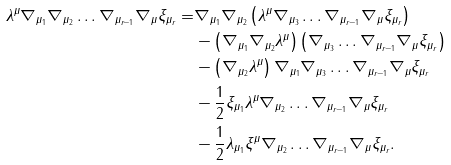Convert formula to latex. <formula><loc_0><loc_0><loc_500><loc_500>\lambda ^ { \mu } \nabla _ { \mu _ { 1 } } \nabla _ { \mu _ { 2 } } \dots \nabla _ { \mu _ { r - 1 } } \nabla _ { \mu } \xi _ { \mu _ { r } } = & \nabla _ { \mu _ { 1 } } \nabla _ { \mu _ { 2 } } \left ( \lambda ^ { \mu } \nabla _ { \mu _ { 3 } } \dots \nabla _ { \mu _ { r - 1 } } \nabla _ { \mu } \xi _ { \mu _ { r } } \right ) \\ & - \left ( \nabla _ { \mu _ { 1 } } \nabla _ { \mu _ { 2 } } \lambda ^ { \mu } \right ) \left ( \nabla _ { \mu _ { 3 } } \dots \nabla _ { \mu _ { r - 1 } } \nabla _ { \mu } \xi _ { \mu _ { r } } \right ) \\ & - \left ( \nabla _ { \mu _ { 2 } } \lambda ^ { \mu } \right ) \nabla _ { \mu _ { 1 } } \nabla _ { \mu _ { 3 } } \dots \nabla _ { \mu _ { r - 1 } } \nabla _ { \mu } \xi _ { \mu _ { r } } \\ & - \frac { 1 } { 2 } \xi _ { \mu _ { 1 } } \lambda ^ { \mu } \nabla _ { \mu _ { 2 } } \dots \nabla _ { \mu _ { r - 1 } } \nabla _ { \mu } \xi _ { \mu _ { r } } \\ & - \frac { 1 } { 2 } \lambda _ { \mu _ { 1 } } \xi ^ { \mu } \nabla _ { \mu _ { 2 } } \dots \nabla _ { \mu _ { r - 1 } } \nabla _ { \mu } \xi _ { \mu _ { r } } .</formula> 